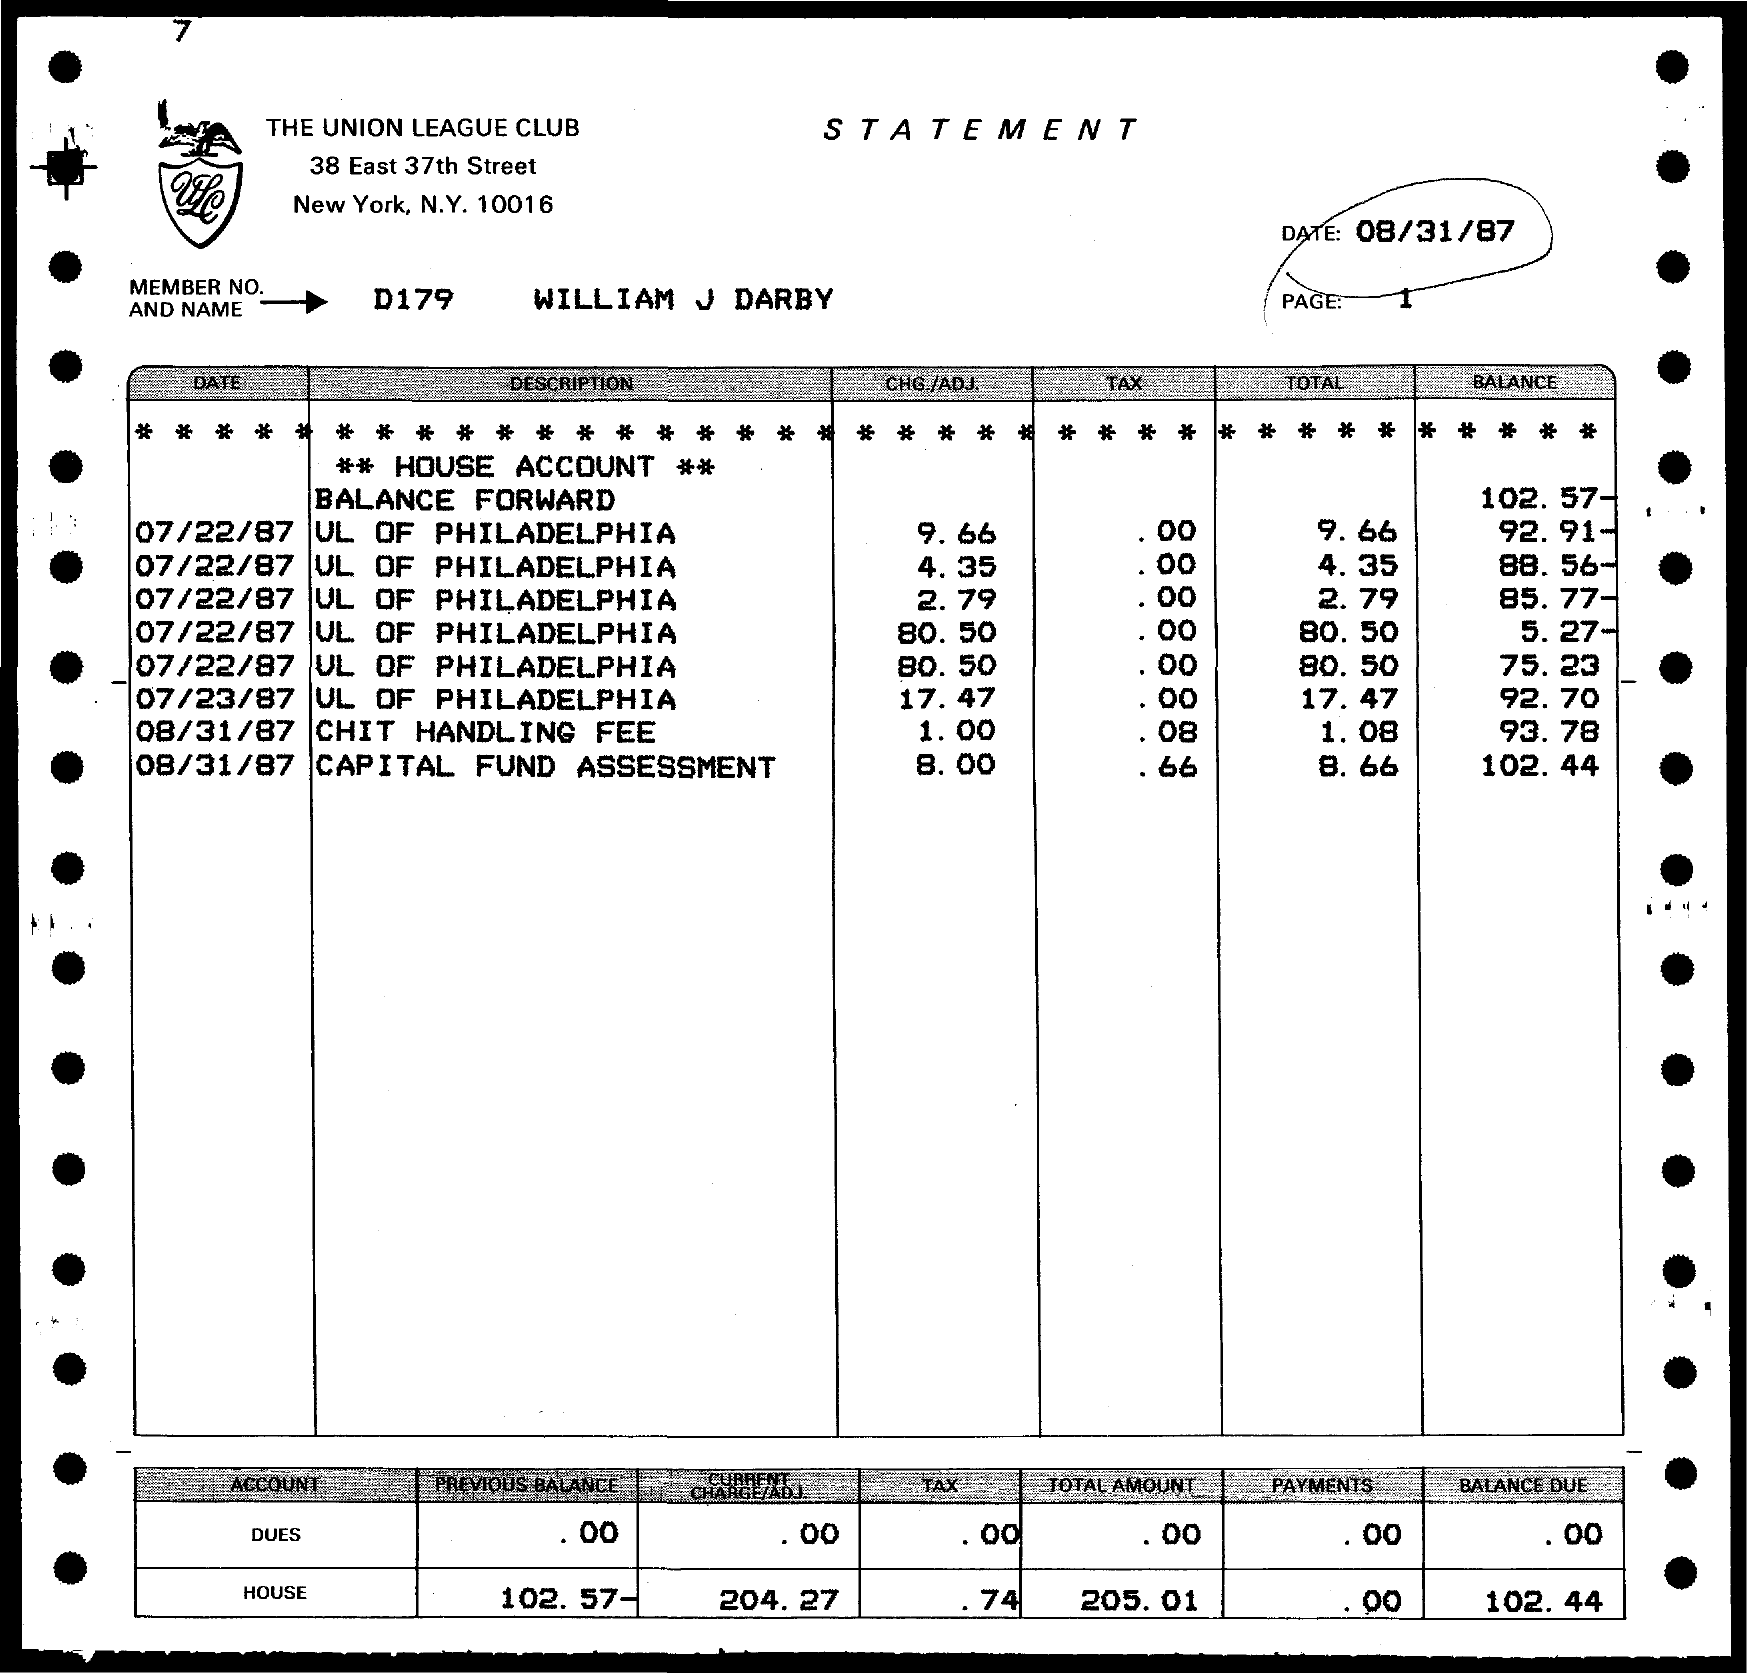What is the date mentioned in the given page ?
Provide a succinct answer. 08/31/87. What is the previous balance of house account mentioned in the given page ?
Provide a short and direct response. 102.57-. What is the amount for current charge in the house account ?
Your response must be concise. 204.27. What is the amount for tax in the house account as mentioned in the given page ?
Offer a very short reply. .74. What is the total amount in the house account mentioned in the given page ?
Offer a terse response. 205.01. What is the amount of balance due in the house account as mentioned in the given page ?
Your answer should be very brief. 102.44. What is the name of the club mentioned in the given page ?
Your answer should be compact. The Union League Club. 